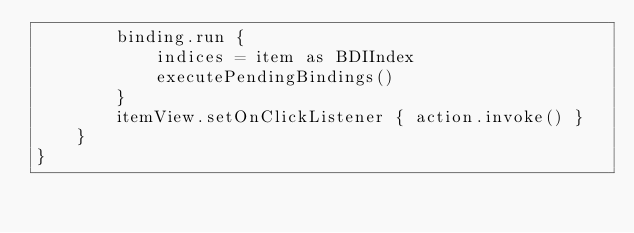<code> <loc_0><loc_0><loc_500><loc_500><_Kotlin_>        binding.run {
            indices = item as BDIIndex
            executePendingBindings()
        }
        itemView.setOnClickListener { action.invoke() }
    }
}</code> 